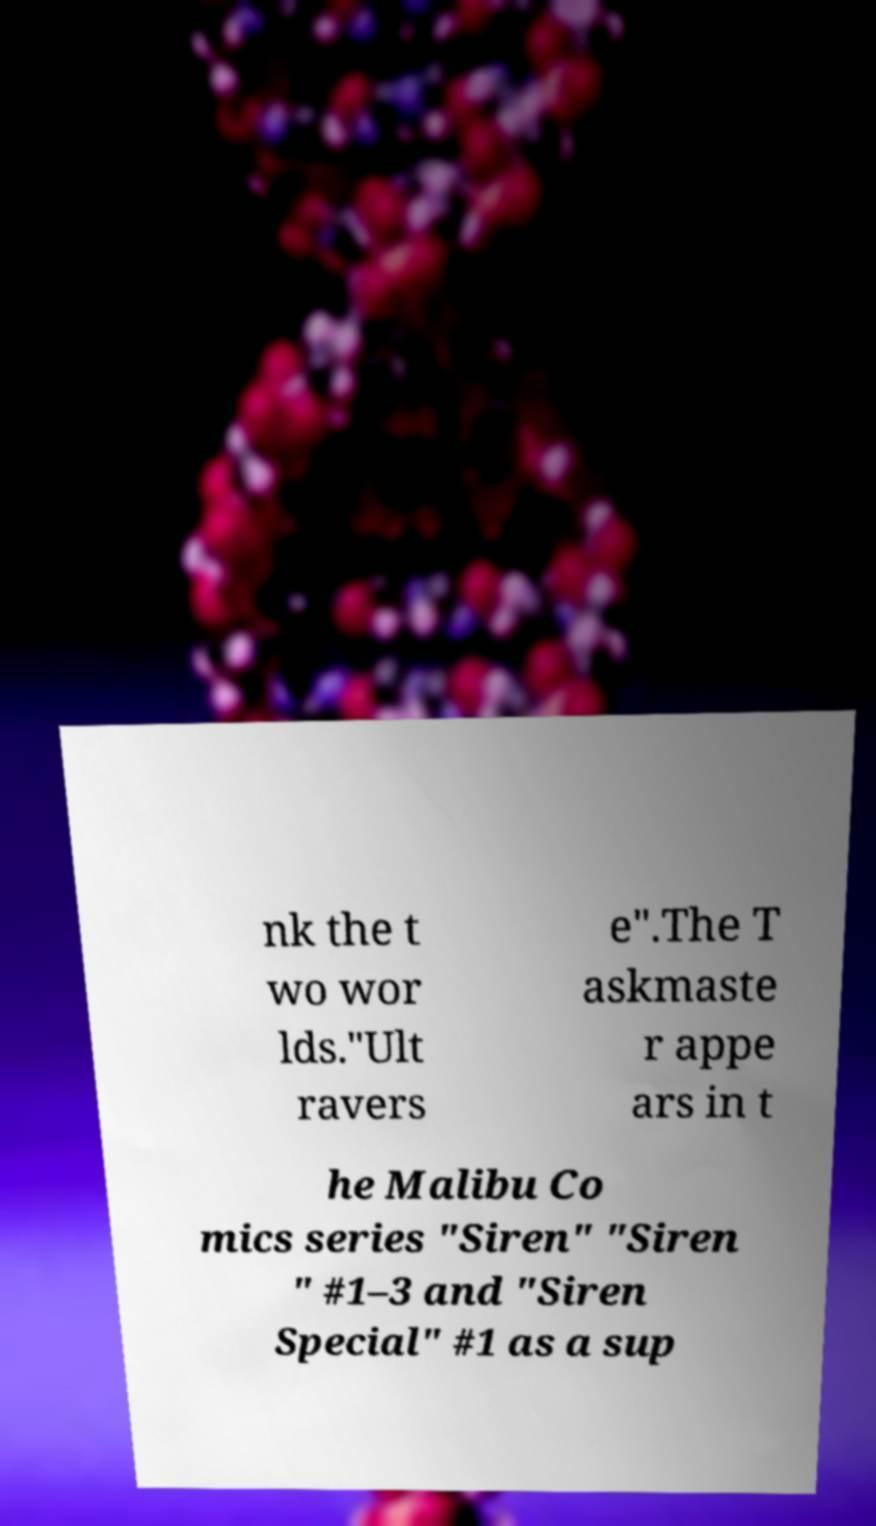Could you extract and type out the text from this image? nk the t wo wor lds."Ult ravers e".The T askmaste r appe ars in t he Malibu Co mics series "Siren" "Siren " #1–3 and "Siren Special" #1 as a sup 